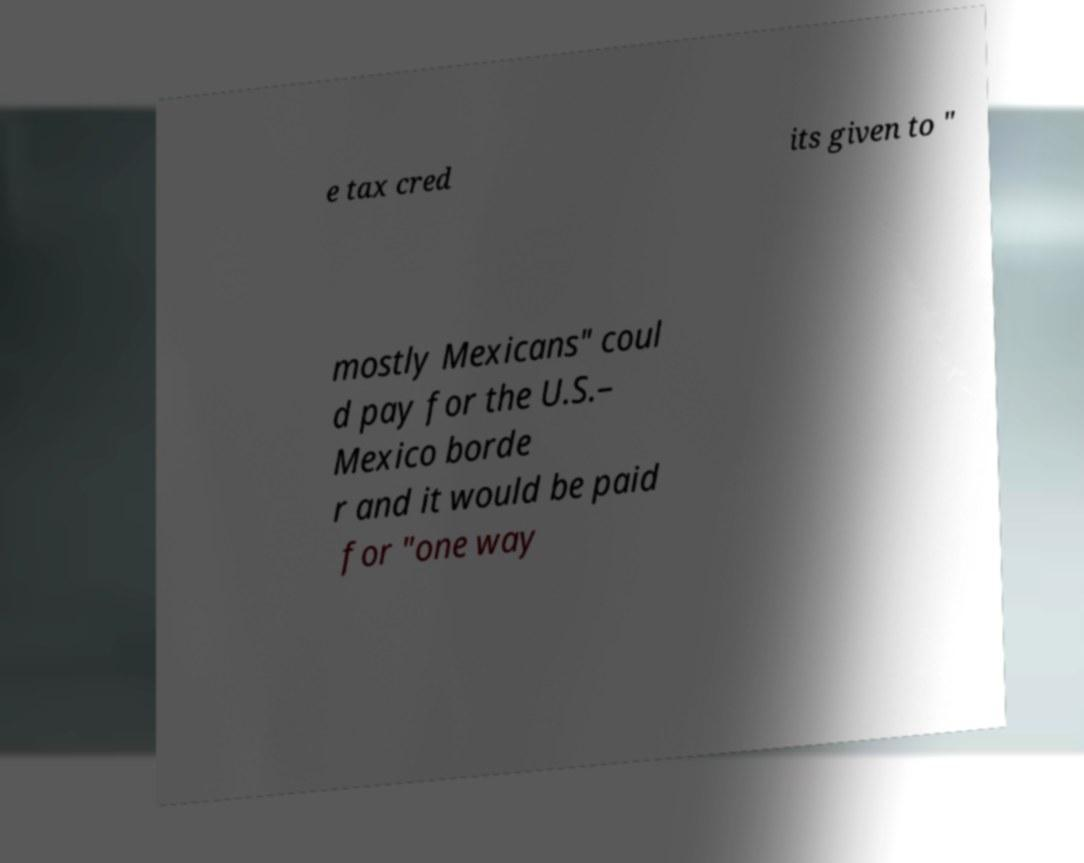For documentation purposes, I need the text within this image transcribed. Could you provide that? e tax cred its given to " mostly Mexicans" coul d pay for the U.S.– Mexico borde r and it would be paid for "one way 